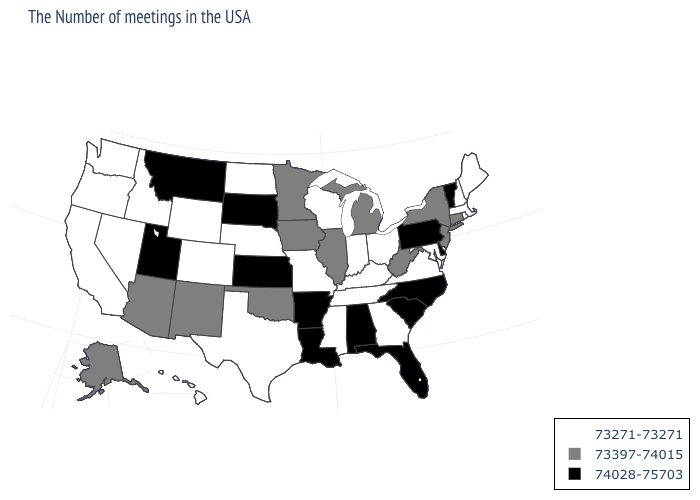Among the states that border Illinois , which have the lowest value?
Answer briefly. Kentucky, Indiana, Wisconsin, Missouri. What is the value of New Mexico?
Give a very brief answer. 73397-74015. Which states have the lowest value in the MidWest?
Write a very short answer. Ohio, Indiana, Wisconsin, Missouri, Nebraska, North Dakota. Name the states that have a value in the range 73397-74015?
Concise answer only. Connecticut, New York, New Jersey, West Virginia, Michigan, Illinois, Minnesota, Iowa, Oklahoma, New Mexico, Arizona, Alaska. What is the lowest value in states that border Oklahoma?
Keep it brief. 73271-73271. Does Oregon have the lowest value in the USA?
Answer briefly. Yes. What is the lowest value in the Northeast?
Keep it brief. 73271-73271. What is the value of Pennsylvania?
Be succinct. 74028-75703. Does Colorado have the highest value in the USA?
Short answer required. No. Among the states that border Montana , does South Dakota have the lowest value?
Concise answer only. No. What is the value of Oklahoma?
Concise answer only. 73397-74015. What is the value of Indiana?
Write a very short answer. 73271-73271. Does the first symbol in the legend represent the smallest category?
Write a very short answer. Yes. What is the lowest value in states that border Michigan?
Answer briefly. 73271-73271. Which states have the lowest value in the South?
Quick response, please. Maryland, Virginia, Georgia, Kentucky, Tennessee, Mississippi, Texas. 